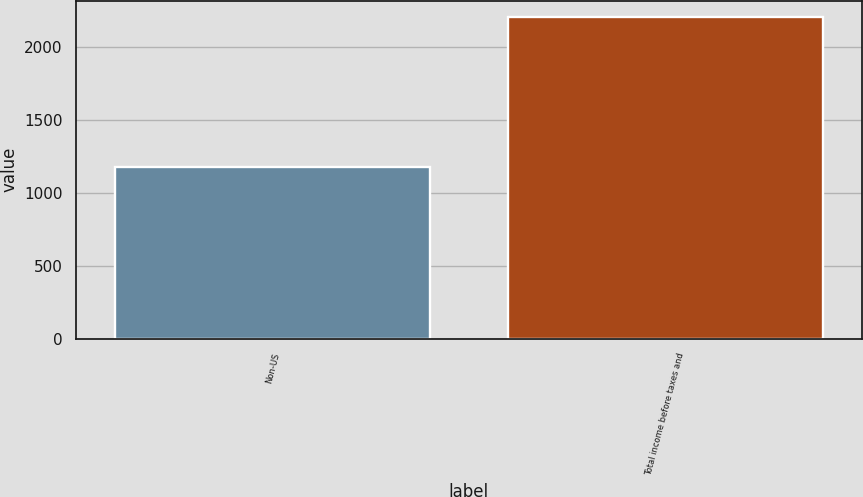<chart> <loc_0><loc_0><loc_500><loc_500><bar_chart><fcel>Non-US<fcel>Total income before taxes and<nl><fcel>1177<fcel>2207<nl></chart> 